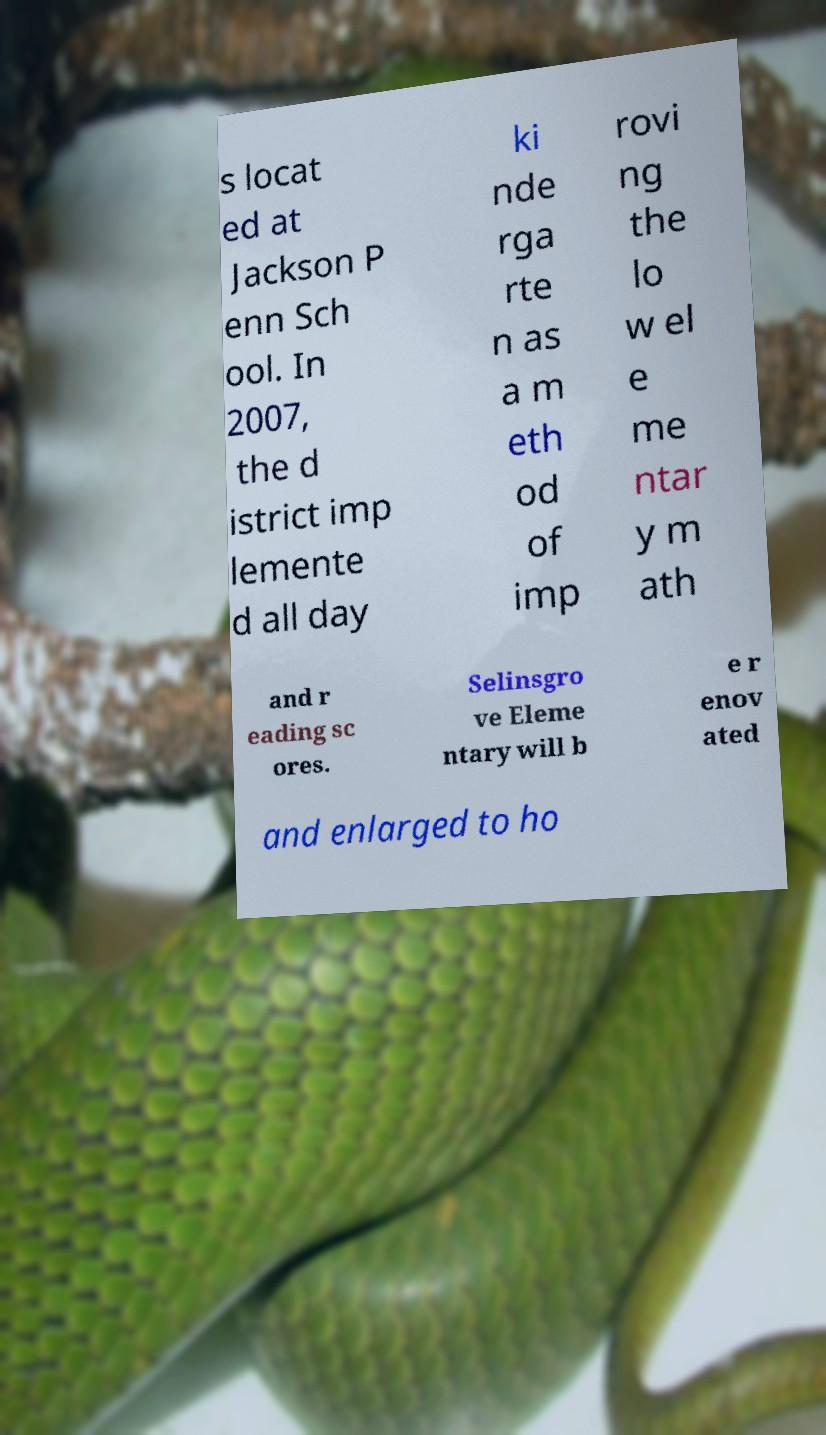Could you assist in decoding the text presented in this image and type it out clearly? s locat ed at Jackson P enn Sch ool. In 2007, the d istrict imp lemente d all day ki nde rga rte n as a m eth od of imp rovi ng the lo w el e me ntar y m ath and r eading sc ores. Selinsgro ve Eleme ntary will b e r enov ated and enlarged to ho 